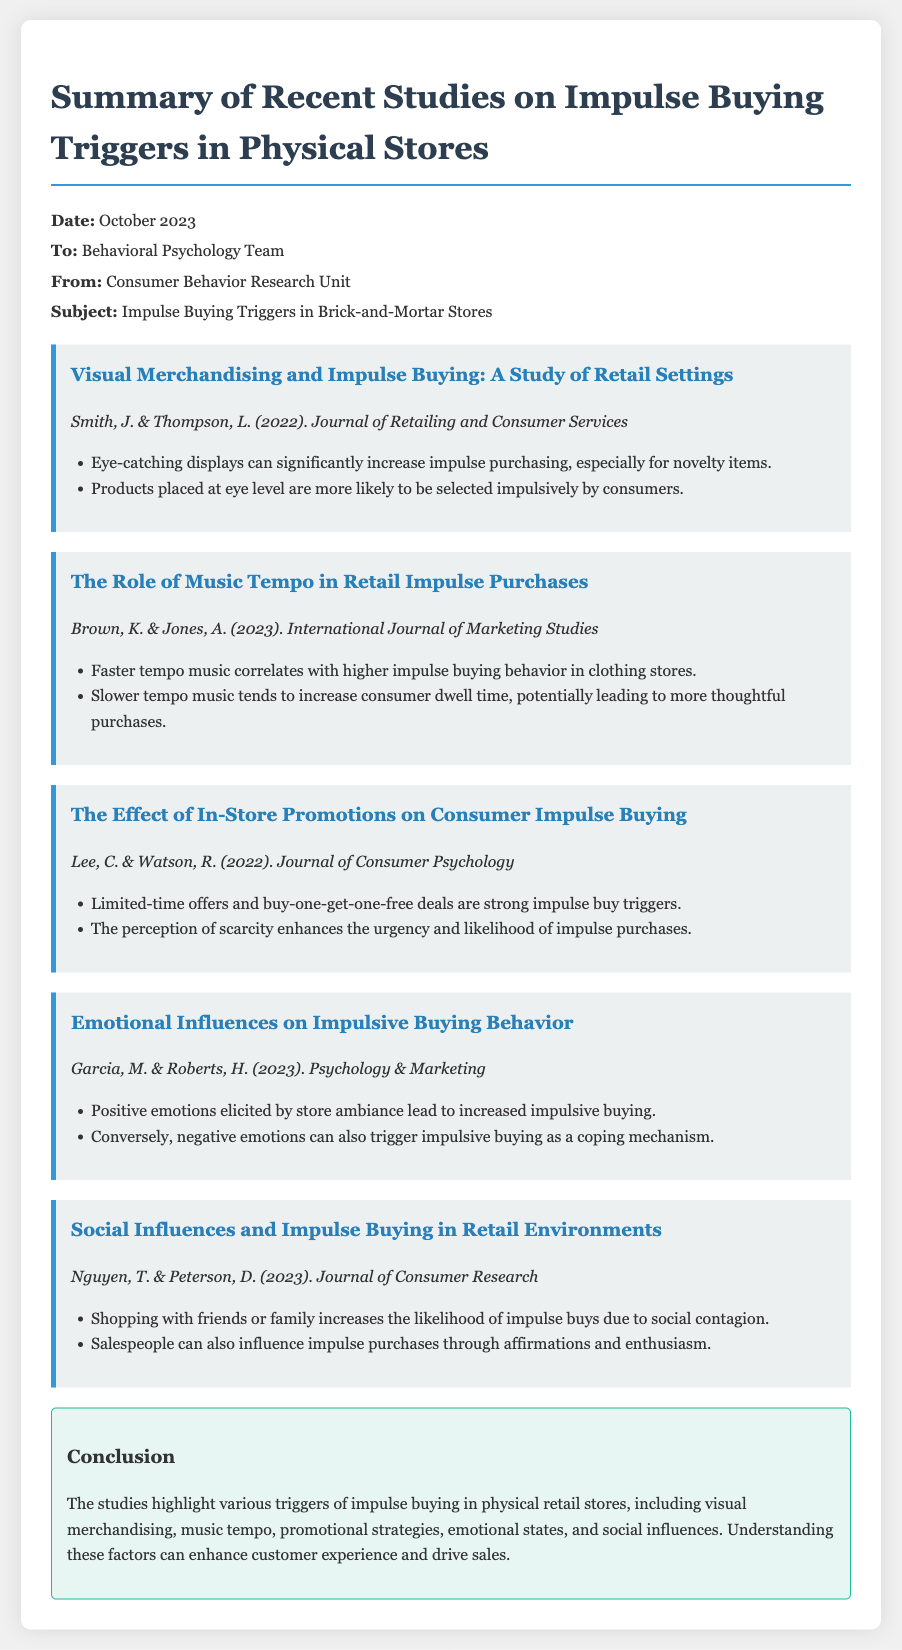what is the title of the memo? The title of the memo is presented at the top and provides the focus of the document.
Answer: Summary of Recent Studies on Impulse Buying Triggers in Physical Stores who are the authors of the study on visual merchandising? The authors of the study can be found in the section dedicated to visual merchandising.
Answer: Smith, J. & Thompson, L what type of music correlates with higher impulse buying? The document describes the relationship between music tempo and impulsive buying behavior.
Answer: Faster tempo music which promotional strategy is identified as a strong impulse buy trigger? The section discussing promotions lists strategies that lead to impulse buying.
Answer: Limited-time offers what is the conclusion about emotional influences on impulse buying? The conclusion summarizes findings related to emotional states and their impact on buying behavior.
Answer: Positive emotions elicit increased impulsive buying what year was the study on social influences published? The publication year for the study on social influences is mentioned in its title section.
Answer: 2023 how do shopping companions affect impulse buying? The document explains the impact of social settings on consumer behavior.
Answer: Increases likelihood which emotional response can trigger impulsive buying as a coping mechanism? The document discusses various emotional reactions that can influence purchasing decisions.
Answer: Negative emotions 